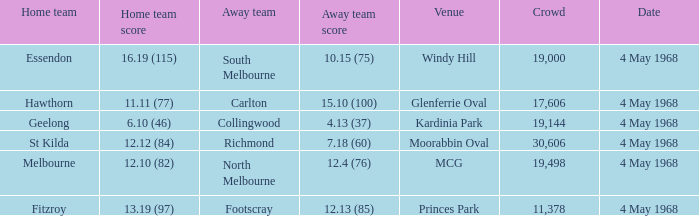What away team played at Kardinia Park? 4.13 (37). 